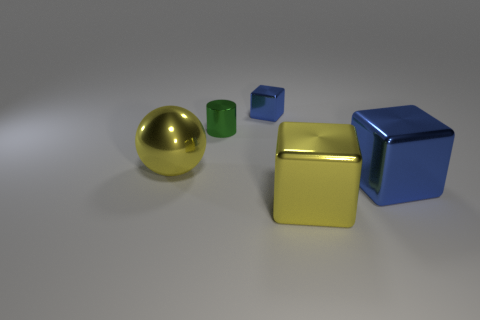Do the shiny cylinder that is right of the ball and the large blue shiny block have the same size?
Offer a terse response. No. Is there anything else that has the same color as the shiny ball?
Provide a succinct answer. Yes. What shape is the blue metallic thing that is the same size as the cylinder?
Provide a succinct answer. Cube. Are there any yellow metallic objects that are behind the blue shiny thing that is behind the large shiny ball?
Keep it short and to the point. No. How many tiny things are either rubber cylinders or shiny objects?
Your answer should be compact. 2. Are there any metallic cubes of the same size as the metallic ball?
Offer a very short reply. Yes. What number of rubber things are either balls or tiny cyan things?
Your response must be concise. 0. There is a object that is the same color as the tiny metallic block; what shape is it?
Keep it short and to the point. Cube. How many large gray rubber cubes are there?
Your response must be concise. 0. Are the yellow thing behind the big blue block and the small thing behind the metallic cylinder made of the same material?
Your answer should be very brief. Yes. 